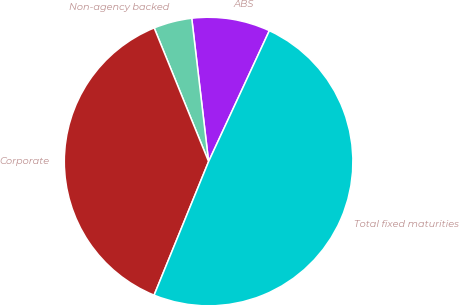<chart> <loc_0><loc_0><loc_500><loc_500><pie_chart><fcel>ABS<fcel>Non-agency backed<fcel>Corporate<fcel>Total fixed maturities<nl><fcel>8.78%<fcel>4.29%<fcel>37.68%<fcel>49.25%<nl></chart> 